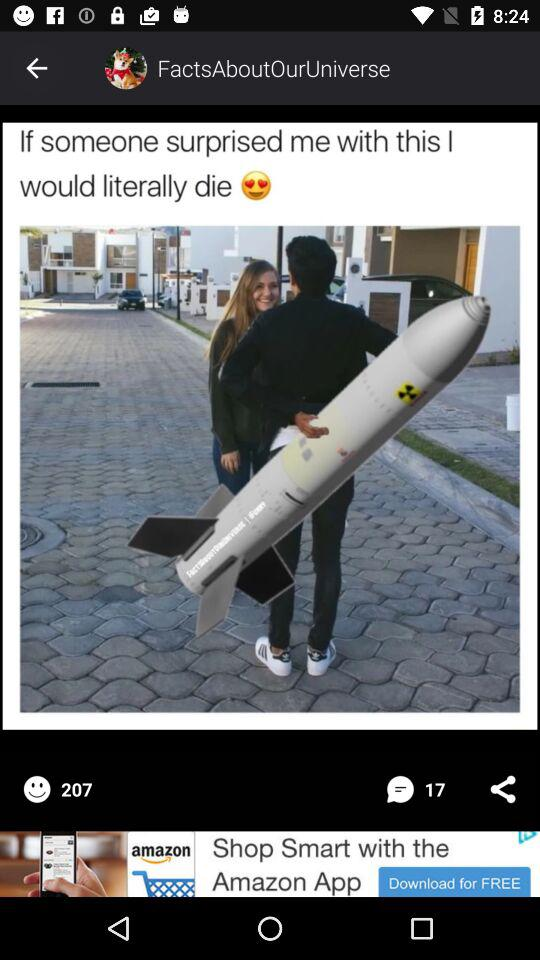How many comments are there? There are 17 comments. 